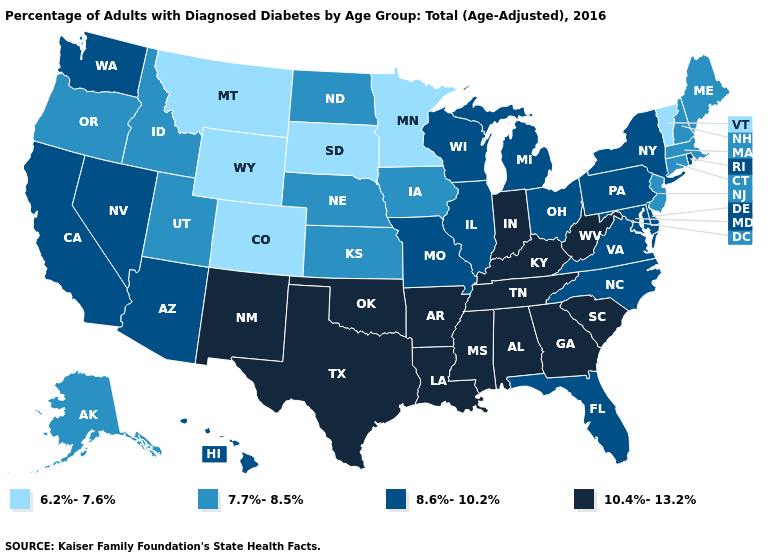Does Nevada have the same value as Connecticut?
Short answer required. No. What is the value of Illinois?
Give a very brief answer. 8.6%-10.2%. What is the value of Vermont?
Quick response, please. 6.2%-7.6%. Does the map have missing data?
Be succinct. No. What is the value of Arkansas?
Concise answer only. 10.4%-13.2%. Which states have the highest value in the USA?
Give a very brief answer. Alabama, Arkansas, Georgia, Indiana, Kentucky, Louisiana, Mississippi, New Mexico, Oklahoma, South Carolina, Tennessee, Texas, West Virginia. What is the highest value in the USA?
Short answer required. 10.4%-13.2%. Does New Jersey have the same value as South Dakota?
Be succinct. No. What is the highest value in states that border Iowa?
Be succinct. 8.6%-10.2%. What is the value of Montana?
Write a very short answer. 6.2%-7.6%. Does Florida have the lowest value in the South?
Quick response, please. Yes. Which states have the lowest value in the USA?
Be succinct. Colorado, Minnesota, Montana, South Dakota, Vermont, Wyoming. Does North Dakota have the lowest value in the MidWest?
Short answer required. No. What is the value of Texas?
Concise answer only. 10.4%-13.2%. What is the value of Nebraska?
Quick response, please. 7.7%-8.5%. 